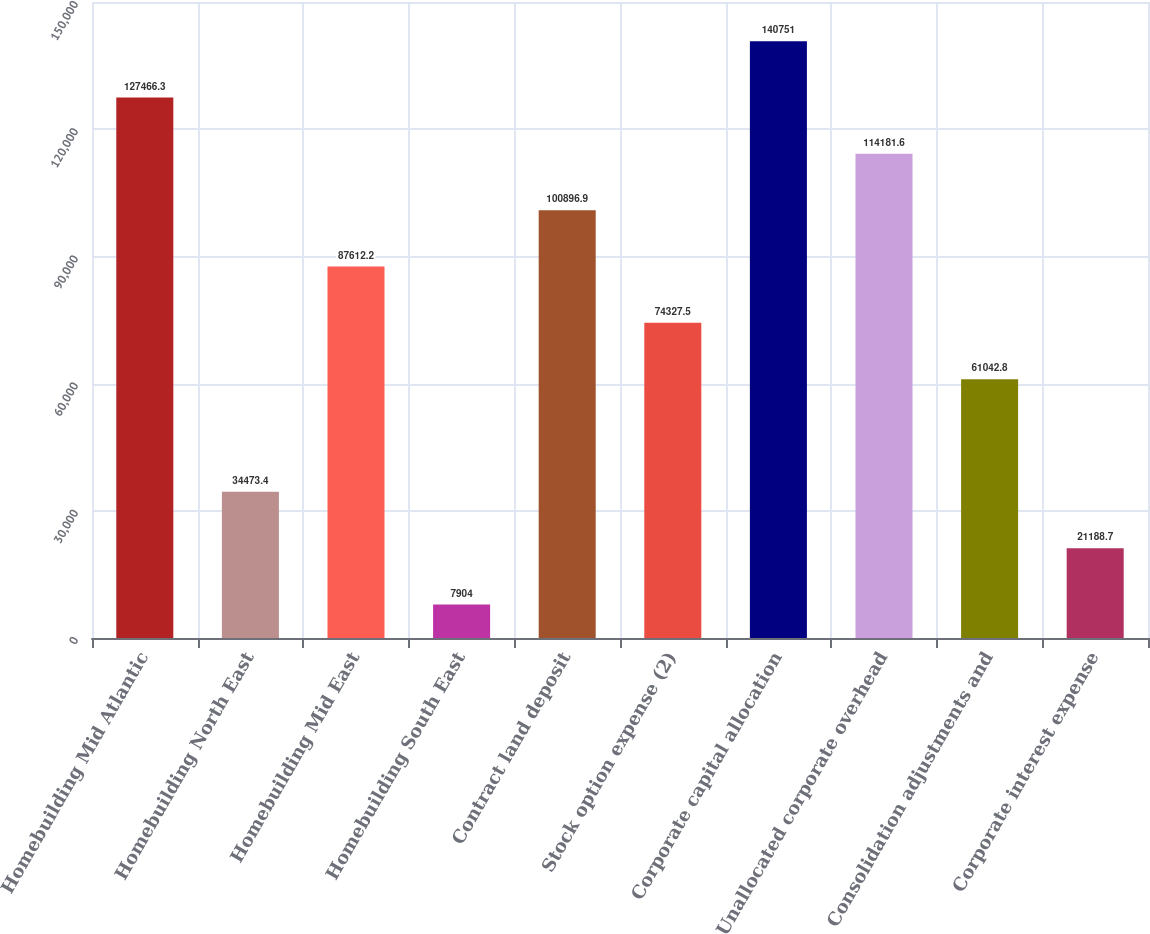<chart> <loc_0><loc_0><loc_500><loc_500><bar_chart><fcel>Homebuilding Mid Atlantic<fcel>Homebuilding North East<fcel>Homebuilding Mid East<fcel>Homebuilding South East<fcel>Contract land deposit<fcel>Stock option expense (2)<fcel>Corporate capital allocation<fcel>Unallocated corporate overhead<fcel>Consolidation adjustments and<fcel>Corporate interest expense<nl><fcel>127466<fcel>34473.4<fcel>87612.2<fcel>7904<fcel>100897<fcel>74327.5<fcel>140751<fcel>114182<fcel>61042.8<fcel>21188.7<nl></chart> 